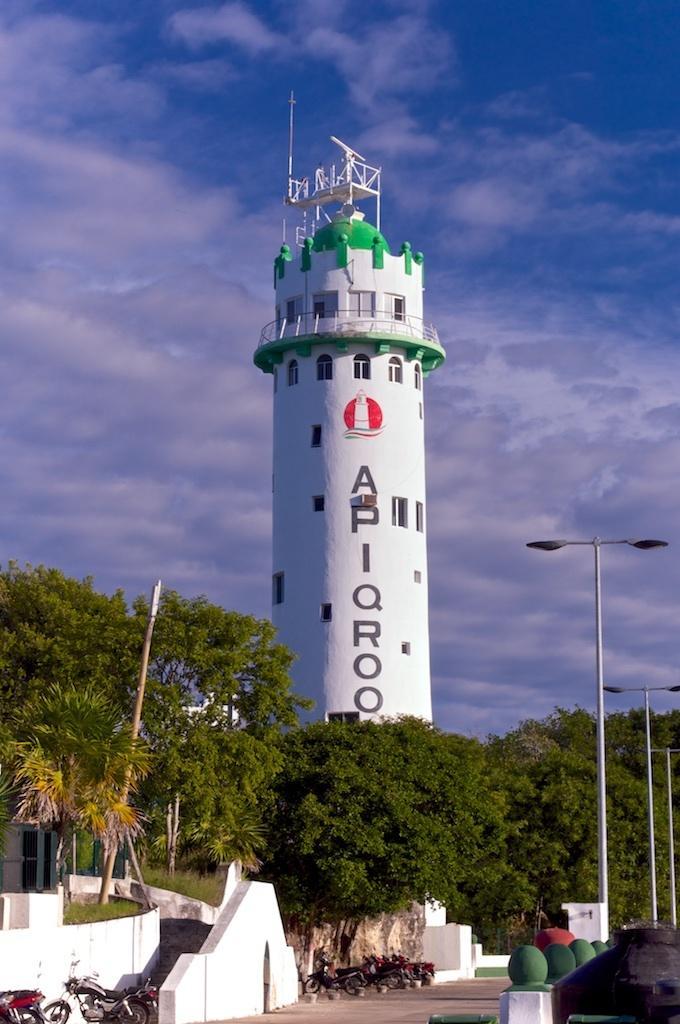Please provide a concise description of this image. In the picture we can see a path near it, we can see a wall and some motorcycles parked near it and behind it, we can see some plants, trees and behind it, we can see a pillar construction type of thing with some railing part of things with a poll on it and in the background we can see a sky with clouds. 